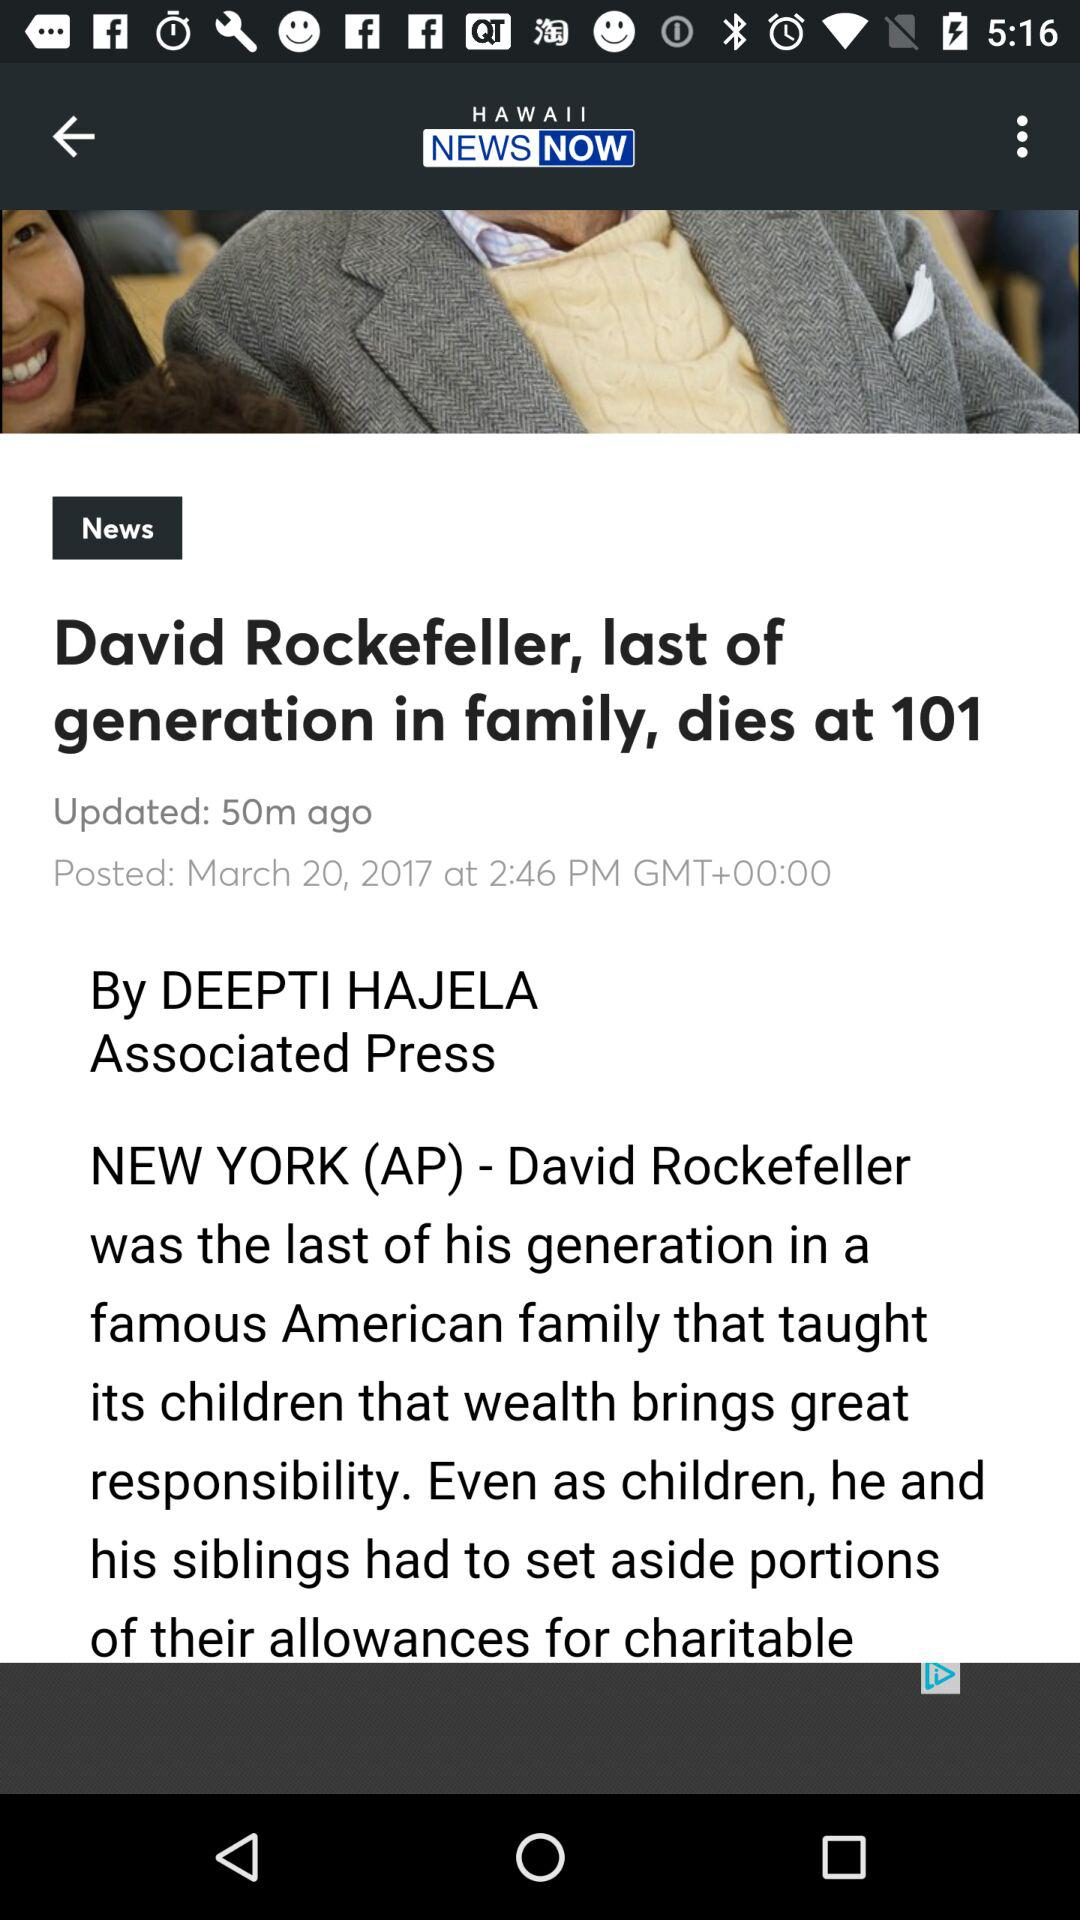What is the news channel name? The news channel name is "HAWAII NEWS NOW". 